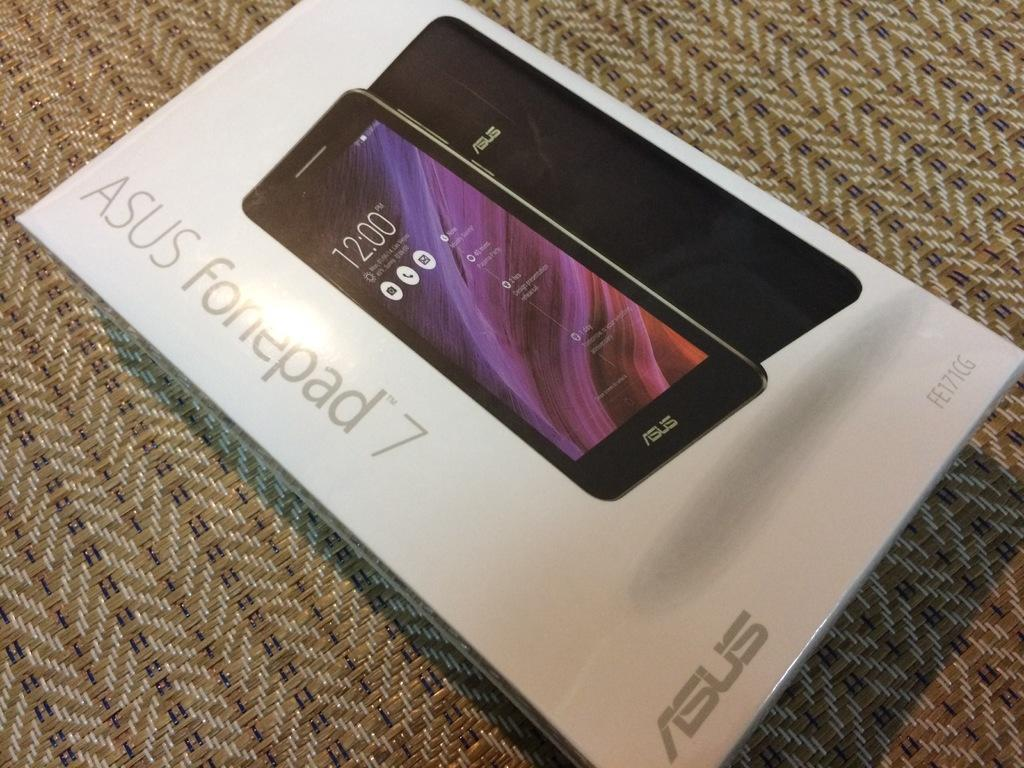<image>
Render a clear and concise summary of the photo. A picture of an ASUS fonepad 7 on a white box. 